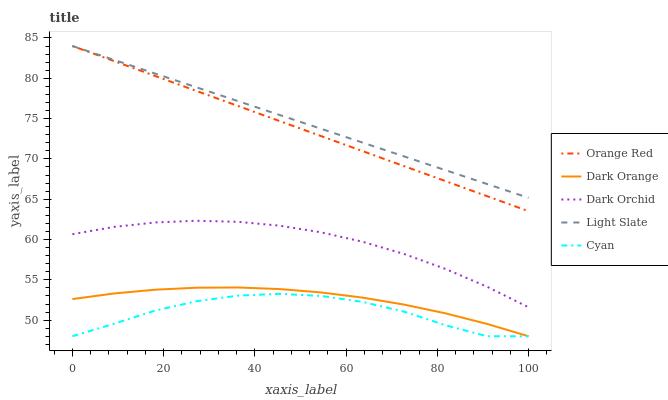Does Cyan have the minimum area under the curve?
Answer yes or no. Yes. Does Light Slate have the maximum area under the curve?
Answer yes or no. Yes. Does Dark Orange have the minimum area under the curve?
Answer yes or no. No. Does Dark Orange have the maximum area under the curve?
Answer yes or no. No. Is Orange Red the smoothest?
Answer yes or no. Yes. Is Cyan the roughest?
Answer yes or no. Yes. Is Dark Orange the smoothest?
Answer yes or no. No. Is Dark Orange the roughest?
Answer yes or no. No. Does Dark Orange have the lowest value?
Answer yes or no. Yes. Does Orange Red have the lowest value?
Answer yes or no. No. Does Orange Red have the highest value?
Answer yes or no. Yes. Does Dark Orange have the highest value?
Answer yes or no. No. Is Cyan less than Orange Red?
Answer yes or no. Yes. Is Orange Red greater than Cyan?
Answer yes or no. Yes. Does Orange Red intersect Light Slate?
Answer yes or no. Yes. Is Orange Red less than Light Slate?
Answer yes or no. No. Is Orange Red greater than Light Slate?
Answer yes or no. No. Does Cyan intersect Orange Red?
Answer yes or no. No. 